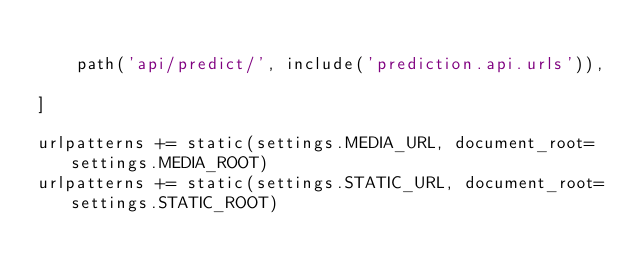Convert code to text. <code><loc_0><loc_0><loc_500><loc_500><_Python_>
    path('api/predict/', include('prediction.api.urls')),

]

urlpatterns += static(settings.MEDIA_URL, document_root=settings.MEDIA_ROOT)
urlpatterns += static(settings.STATIC_URL, document_root=settings.STATIC_ROOT)
</code> 